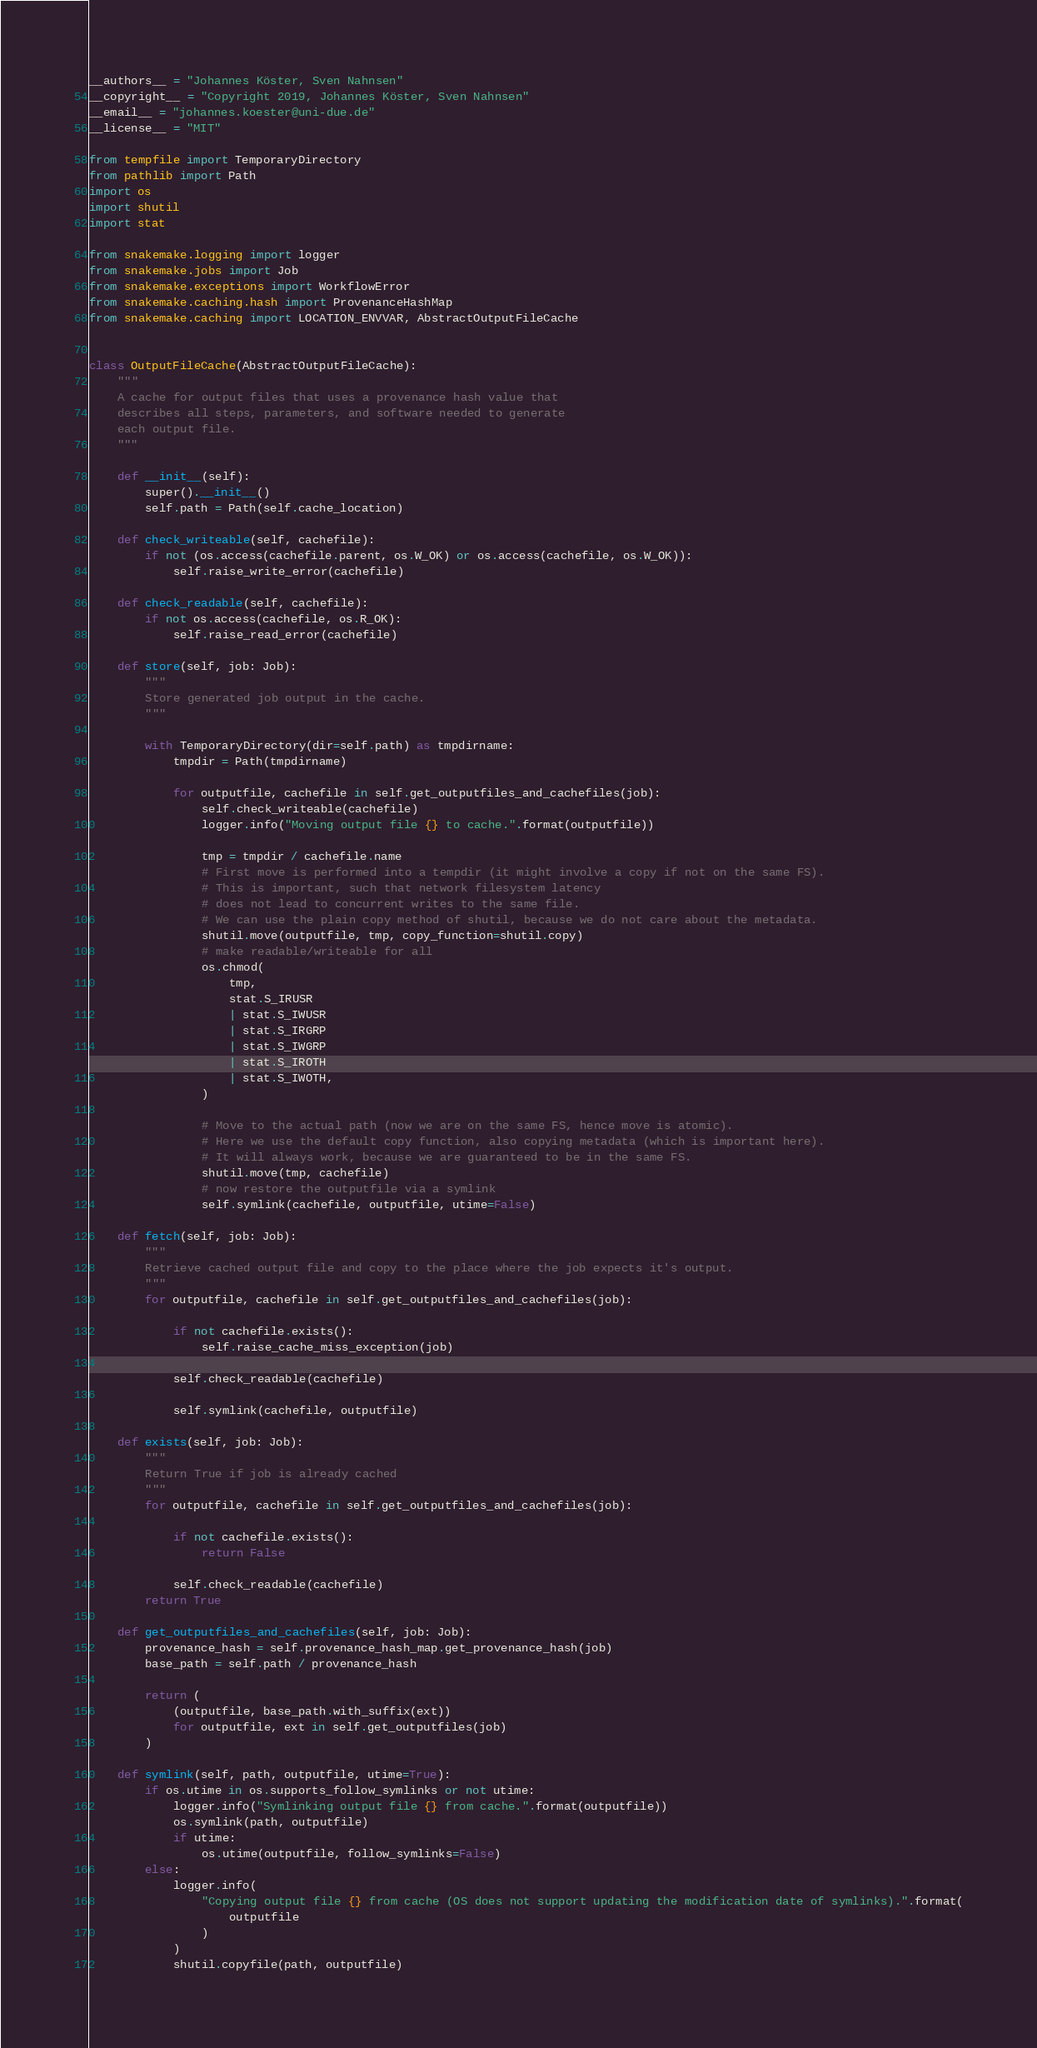Convert code to text. <code><loc_0><loc_0><loc_500><loc_500><_Python_>__authors__ = "Johannes Köster, Sven Nahnsen"
__copyright__ = "Copyright 2019, Johannes Köster, Sven Nahnsen"
__email__ = "johannes.koester@uni-due.de"
__license__ = "MIT"

from tempfile import TemporaryDirectory
from pathlib import Path
import os
import shutil
import stat

from snakemake.logging import logger
from snakemake.jobs import Job
from snakemake.exceptions import WorkflowError
from snakemake.caching.hash import ProvenanceHashMap
from snakemake.caching import LOCATION_ENVVAR, AbstractOutputFileCache


class OutputFileCache(AbstractOutputFileCache):
    """
    A cache for output files that uses a provenance hash value that
    describes all steps, parameters, and software needed to generate
    each output file.
    """

    def __init__(self):
        super().__init__()
        self.path = Path(self.cache_location)

    def check_writeable(self, cachefile):
        if not (os.access(cachefile.parent, os.W_OK) or os.access(cachefile, os.W_OK)):
            self.raise_write_error(cachefile)

    def check_readable(self, cachefile):
        if not os.access(cachefile, os.R_OK):
            self.raise_read_error(cachefile)

    def store(self, job: Job):
        """
        Store generated job output in the cache.
        """

        with TemporaryDirectory(dir=self.path) as tmpdirname:
            tmpdir = Path(tmpdirname)

            for outputfile, cachefile in self.get_outputfiles_and_cachefiles(job):
                self.check_writeable(cachefile)
                logger.info("Moving output file {} to cache.".format(outputfile))

                tmp = tmpdir / cachefile.name
                # First move is performed into a tempdir (it might involve a copy if not on the same FS).
                # This is important, such that network filesystem latency
                # does not lead to concurrent writes to the same file.
                # We can use the plain copy method of shutil, because we do not care about the metadata.
                shutil.move(outputfile, tmp, copy_function=shutil.copy)
                # make readable/writeable for all
                os.chmod(
                    tmp,
                    stat.S_IRUSR
                    | stat.S_IWUSR
                    | stat.S_IRGRP
                    | stat.S_IWGRP
                    | stat.S_IROTH
                    | stat.S_IWOTH,
                )

                # Move to the actual path (now we are on the same FS, hence move is atomic).
                # Here we use the default copy function, also copying metadata (which is important here).
                # It will always work, because we are guaranteed to be in the same FS.
                shutil.move(tmp, cachefile)
                # now restore the outputfile via a symlink
                self.symlink(cachefile, outputfile, utime=False)

    def fetch(self, job: Job):
        """
        Retrieve cached output file and copy to the place where the job expects it's output.
        """
        for outputfile, cachefile in self.get_outputfiles_and_cachefiles(job):

            if not cachefile.exists():
                self.raise_cache_miss_exception(job)

            self.check_readable(cachefile)

            self.symlink(cachefile, outputfile)

    def exists(self, job: Job):
        """
        Return True if job is already cached
        """
        for outputfile, cachefile in self.get_outputfiles_and_cachefiles(job):

            if not cachefile.exists():
                return False

            self.check_readable(cachefile)
        return True

    def get_outputfiles_and_cachefiles(self, job: Job):
        provenance_hash = self.provenance_hash_map.get_provenance_hash(job)
        base_path = self.path / provenance_hash

        return (
            (outputfile, base_path.with_suffix(ext))
            for outputfile, ext in self.get_outputfiles(job)
        )

    def symlink(self, path, outputfile, utime=True):
        if os.utime in os.supports_follow_symlinks or not utime:
            logger.info("Symlinking output file {} from cache.".format(outputfile))
            os.symlink(path, outputfile)
            if utime:
                os.utime(outputfile, follow_symlinks=False)
        else:
            logger.info(
                "Copying output file {} from cache (OS does not support updating the modification date of symlinks).".format(
                    outputfile
                )
            )
            shutil.copyfile(path, outputfile)
</code> 